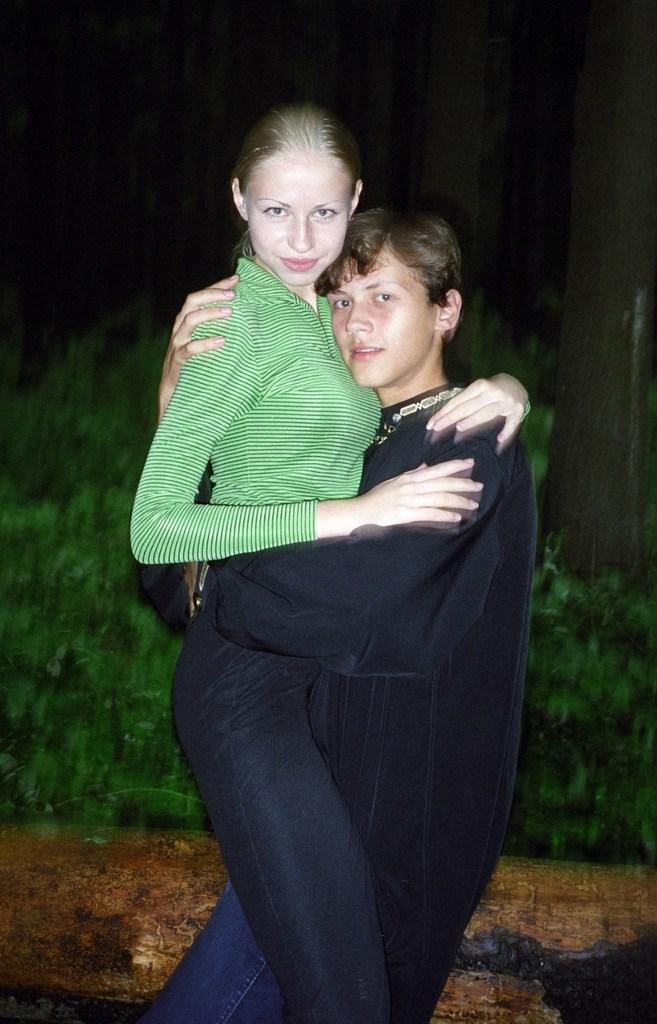How many people are in the image? There are two people in the image, a man and a woman. What is the woman wearing on her upper body? The woman is wearing a green top. What is the woman wearing on her lower body? The woman is wearing black pants. What can be observed about the background of the image? The background of the image is dark. What type of lettuce is being used as a design element in the woman's top? There is no lettuce present in the image, nor is it being used as a design element in the woman's top. How many birds can be seen flying in the background of the image? There are no birds visible in the image, so it is not possible to determine how many might be present. 